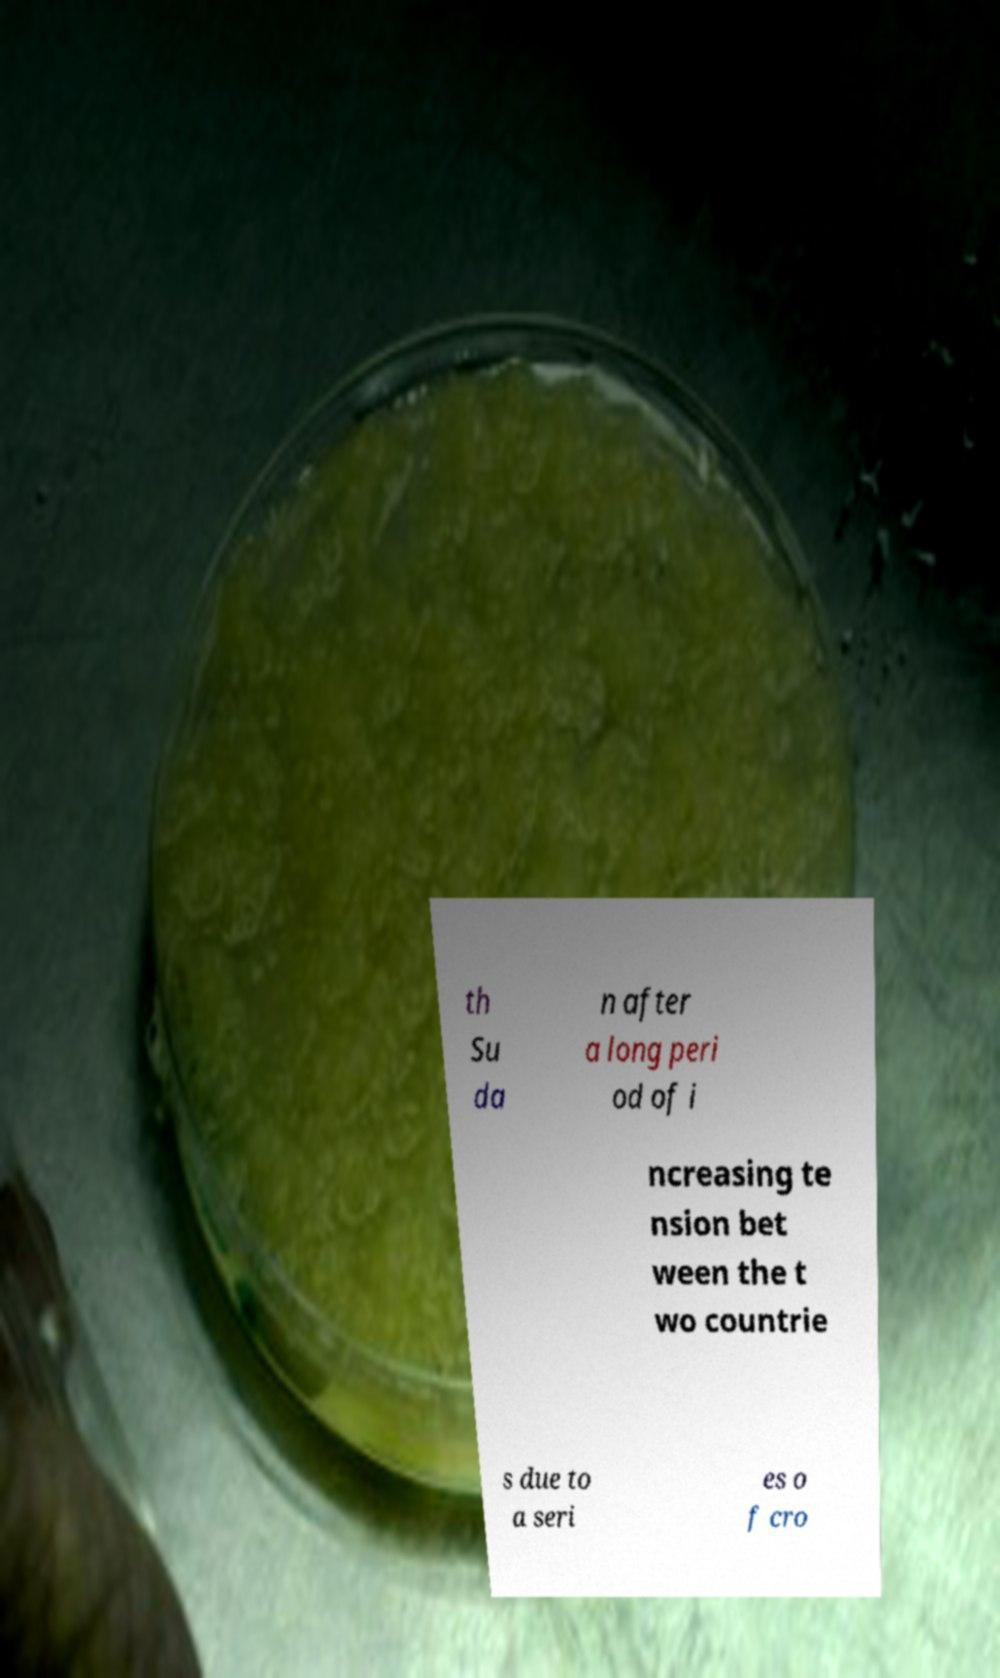Please identify and transcribe the text found in this image. th Su da n after a long peri od of i ncreasing te nsion bet ween the t wo countrie s due to a seri es o f cro 